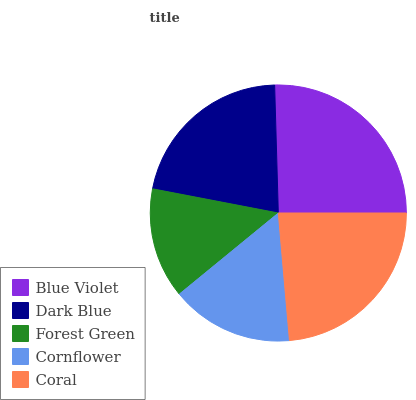Is Forest Green the minimum?
Answer yes or no. Yes. Is Blue Violet the maximum?
Answer yes or no. Yes. Is Dark Blue the minimum?
Answer yes or no. No. Is Dark Blue the maximum?
Answer yes or no. No. Is Blue Violet greater than Dark Blue?
Answer yes or no. Yes. Is Dark Blue less than Blue Violet?
Answer yes or no. Yes. Is Dark Blue greater than Blue Violet?
Answer yes or no. No. Is Blue Violet less than Dark Blue?
Answer yes or no. No. Is Dark Blue the high median?
Answer yes or no. Yes. Is Dark Blue the low median?
Answer yes or no. Yes. Is Blue Violet the high median?
Answer yes or no. No. Is Coral the low median?
Answer yes or no. No. 